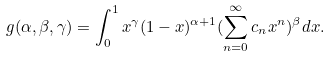Convert formula to latex. <formula><loc_0><loc_0><loc_500><loc_500>g ( \alpha , \beta , \gamma ) = \int _ { 0 } ^ { 1 } x ^ { \gamma } ( 1 - x ) ^ { \alpha + 1 } ( \sum ^ { \infty } _ { n = 0 } c _ { n } x ^ { n } ) ^ { \beta } d x .</formula> 